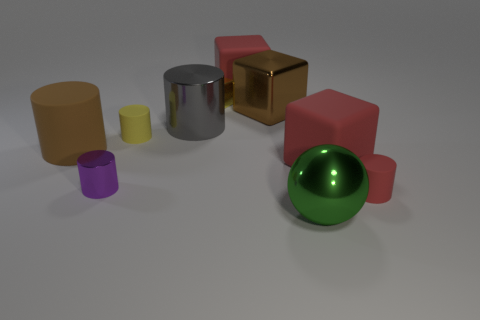Subtract all small shiny cylinders. How many cylinders are left? 4 Subtract all yellow cylinders. How many cylinders are left? 4 Subtract all cyan cylinders. Subtract all gray spheres. How many cylinders are left? 5 Subtract all blocks. How many objects are left? 6 Subtract all brown metallic things. Subtract all small red balls. How many objects are left? 9 Add 3 tiny yellow matte cylinders. How many tiny yellow matte cylinders are left? 4 Add 8 large blue matte spheres. How many large blue matte spheres exist? 8 Subtract 1 gray cylinders. How many objects are left? 9 